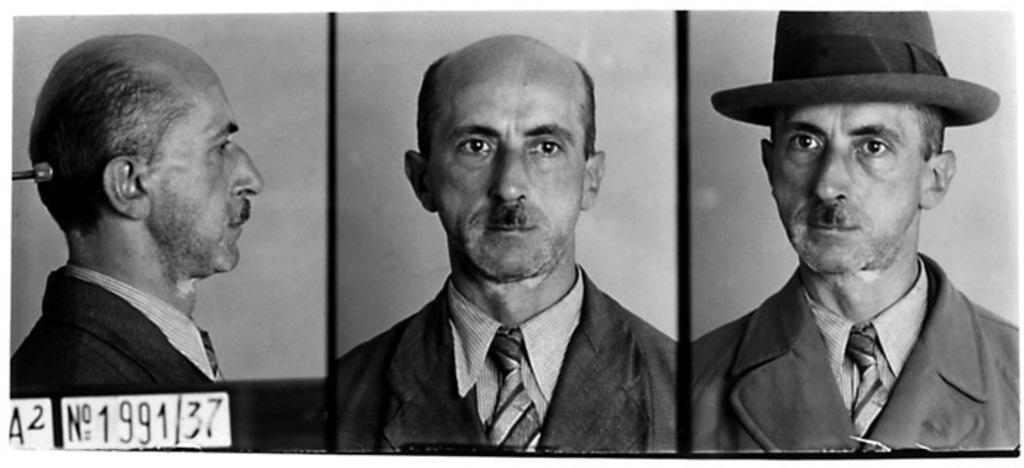Describe this image in one or two sentences. Here in this picture we can see a collage of a person, in which on the right side we can see the person wearing a coat and hat and in the middle we can see the person is wearing only the coat and on the left side we can see the person is showing his side view over there. 